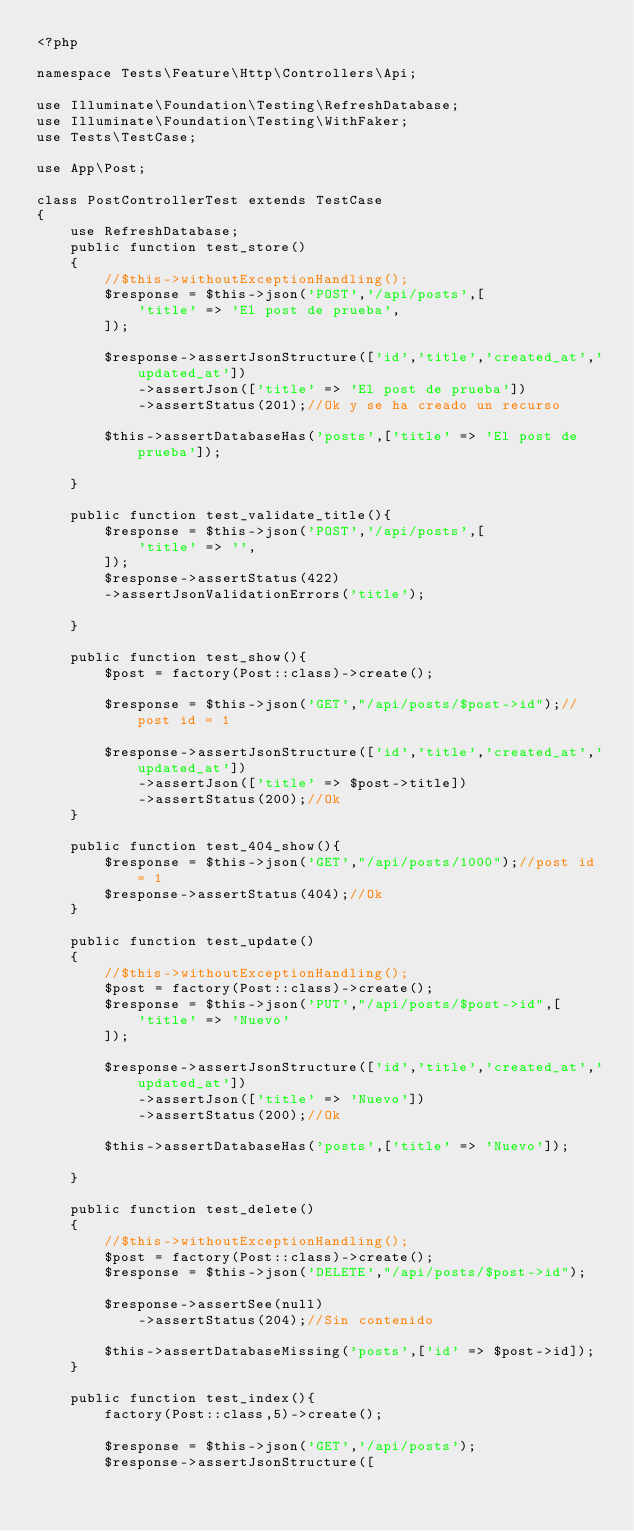<code> <loc_0><loc_0><loc_500><loc_500><_PHP_><?php

namespace Tests\Feature\Http\Controllers\Api;

use Illuminate\Foundation\Testing\RefreshDatabase;
use Illuminate\Foundation\Testing\WithFaker;
use Tests\TestCase;

use App\Post;

class PostControllerTest extends TestCase
{
    use RefreshDatabase;
    public function test_store()
    {
        //$this->withoutExceptionHandling();
        $response = $this->json('POST','/api/posts',[
            'title' => 'El post de prueba',
        ]);

        $response->assertJsonStructure(['id','title','created_at','updated_at'])
            ->assertJson(['title' => 'El post de prueba'])
            ->assertStatus(201);//Ok y se ha creado un recurso

        $this->assertDatabaseHas('posts',['title' => 'El post de prueba']);

    }

    public function test_validate_title(){
        $response = $this->json('POST','/api/posts',[
            'title' => '',
        ]);
        $response->assertStatus(422)
        ->assertJsonValidationErrors('title');

    }

    public function test_show(){
        $post = factory(Post::class)->create();

        $response = $this->json('GET',"/api/posts/$post->id");//post id = 1

        $response->assertJsonStructure(['id','title','created_at','updated_at'])
            ->assertJson(['title' => $post->title])
            ->assertStatus(200);//Ok
    }

    public function test_404_show(){
        $response = $this->json('GET',"/api/posts/1000");//post id = 1
        $response->assertStatus(404);//Ok
    }

    public function test_update()
    {
        //$this->withoutExceptionHandling();
        $post = factory(Post::class)->create();
        $response = $this->json('PUT',"/api/posts/$post->id",[
            'title' => 'Nuevo'
        ]);

        $response->assertJsonStructure(['id','title','created_at','updated_at'])
            ->assertJson(['title' => 'Nuevo'])
            ->assertStatus(200);//Ok

        $this->assertDatabaseHas('posts',['title' => 'Nuevo']);

    }

    public function test_delete()
    {
        //$this->withoutExceptionHandling();
        $post = factory(Post::class)->create();
        $response = $this->json('DELETE',"/api/posts/$post->id");

        $response->assertSee(null)
            ->assertStatus(204);//Sin contenido

        $this->assertDatabaseMissing('posts',['id' => $post->id]);
    }

    public function test_index(){
        factory(Post::class,5)->create();

        $response = $this->json('GET','/api/posts');
        $response->assertJsonStructure([</code> 